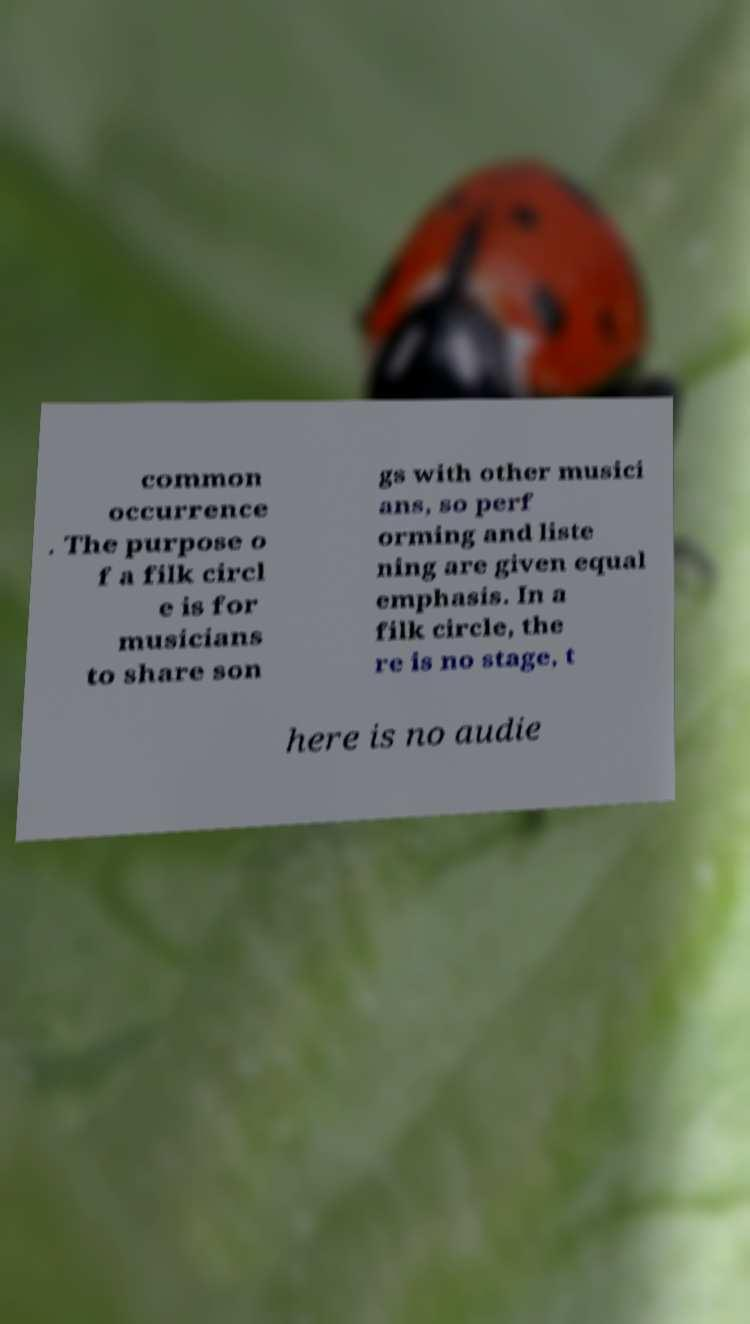I need the written content from this picture converted into text. Can you do that? common occurrence . The purpose o f a filk circl e is for musicians to share son gs with other musici ans, so perf orming and liste ning are given equal emphasis. In a filk circle, the re is no stage, t here is no audie 